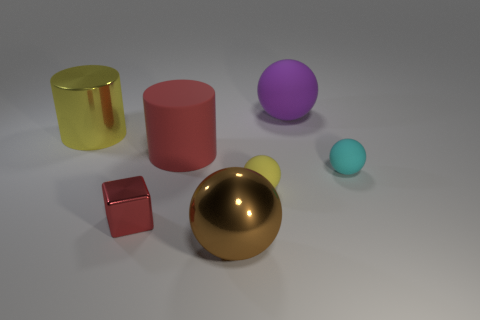Subtract all cyan rubber balls. How many balls are left? 3 Add 2 gray matte cubes. How many objects exist? 9 Subtract 1 cylinders. How many cylinders are left? 1 Subtract all brown spheres. How many spheres are left? 3 Subtract all blue blocks. Subtract all brown cylinders. How many blocks are left? 1 Subtract all yellow blocks. How many purple spheres are left? 1 Subtract all green rubber cylinders. Subtract all red matte cylinders. How many objects are left? 6 Add 7 big yellow metallic objects. How many big yellow metallic objects are left? 8 Add 7 tiny rubber things. How many tiny rubber things exist? 9 Subtract 1 purple balls. How many objects are left? 6 